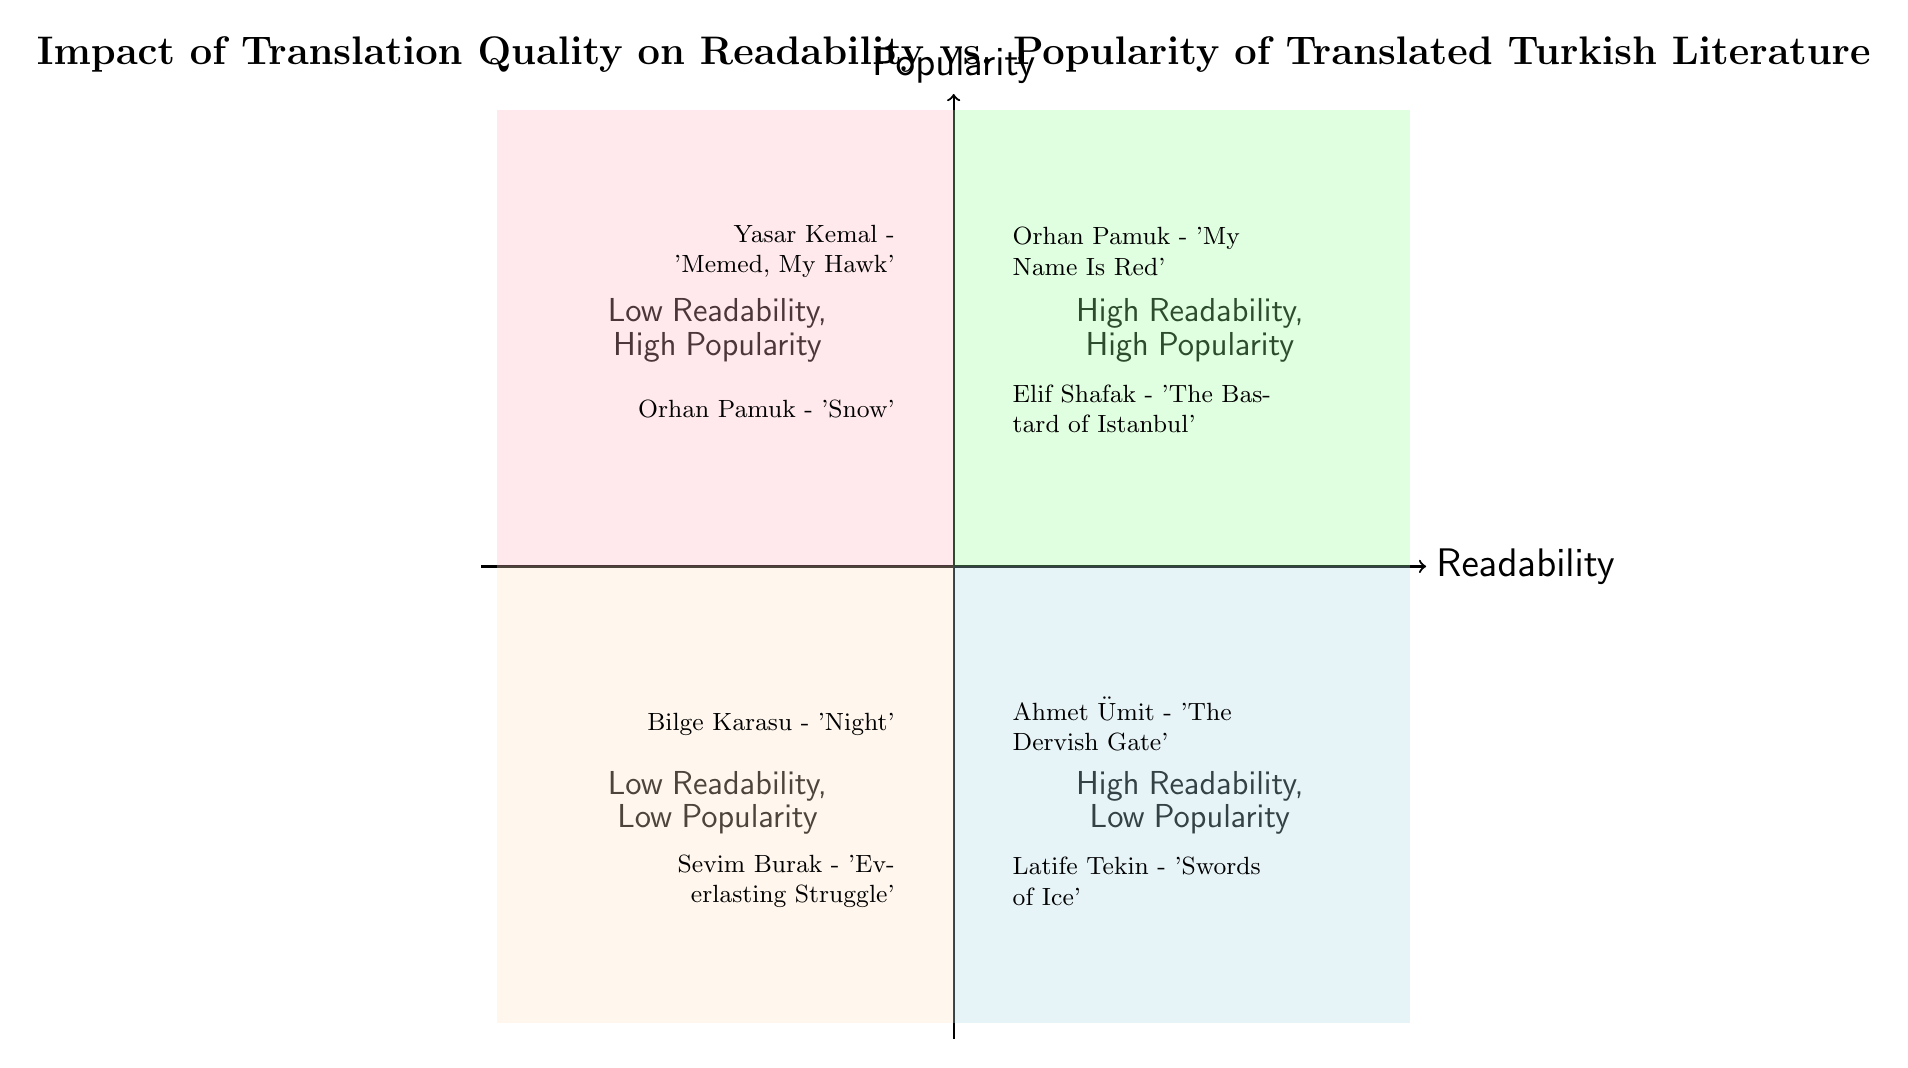What two works are in the High Readability, High Popularity quadrant? The diagram labels the "High Readability, High Popularity" quadrant and lists the works in that section. Upon examining, the works are "Orhan Pamuk - 'My Name Is Red'" and "Elif Shafak - 'The Bastard of Istanbul'."
Answer: Orhan Pamuk - 'My Name Is Red', Elif Shafak - 'The Bastard of Istanbul' How many works are categorized in the Low Readability, Low Popularity quadrant? By looking at the "Low Readability, Low Popularity" quadrant, I can see that there are two works listed: "Bilge Karasu - 'Night'" and "Sevim Burak - 'Everlasting Struggle'." Therefore, the total count of works in that quadrant is two.
Answer: 2 Which quadrant contains "Ahmet Ümit - 'The Dervish Gate'"? The diagram clearly indicates that "Ahmet Ümit - 'The Dervish Gate'" is located in the "High Readability, Low Popularity" quadrant. Observing the layout, this piece is specifically listed in that section.
Answer: High Readability, Low Popularity What can we infer about the readability of "Yasar Kemal - 'Memed, My Hawk'"? "Yasar Kemal - 'Memed, My Hawk'" appears in the "Low Readability, High Popularity" quadrant of the diagram. This shows that, despite its popularity, its readability is perceived to be low.
Answer: Low Readability Which quadrant represents works with high popularity but low readability? The quadrant that shows works classified as having high popularity but low readability is clearly marked as "Low Readability, High Popularity." This is a standard categorization based on the axes provided in the chart.
Answer: Low Readability, High Popularity How many authors appear in the High Readability, Low Popularity quadrant? In the "High Readability, Low Popularity" quadrant, there are two authors represented: Ahmet Ümit and Latife Tekin. Each author corresponds to a work listed in that section of the diagram, bringing the total to two authors.
Answer: 2 Which translated work by Orhan Pamuk is classified in the Low Readability quadrant? Looking at the diagram, I find that "Orhan Pamuk - 'Snow'" is positioned in the "Low Readability, High Popularity" quadrant. To focus specifically on the low readability aspect, I identify "Snow" as the pertinent work.
Answer: Snow Are there any works in the Low Readability, High Popularity quadrant? Yes, upon inspecting the quadrant labeled "Low Readability, High Popularity," I observe that there are indeed two works: "Yasar Kemal - 'Memed, My Hawk'" and "Orhan Pamuk - 'Snow'."
Answer: Yes 